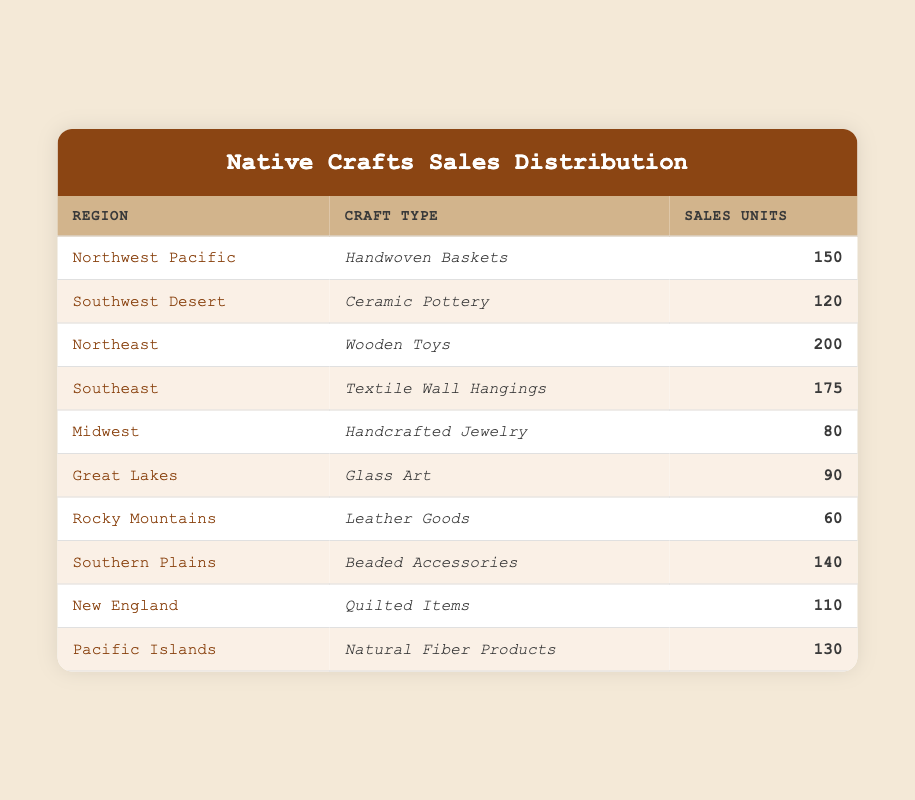What's the total number of sales units for crafts in the Northeast region? The Northeast region has 200 sales units for Wooden Toys. No additional calculations are needed.
Answer: 200 Which craft type sold the least across all regions? The Rocky Mountains had the least sales with Leather Goods at 60 units.
Answer: Leather Goods How many sales units were sold for crafts in the Southern Plains and Southwest Desert combined? Southern Plains has 140 sales units (Beaded Accessories) and Southwest Desert has 120 sales units (Ceramic Pottery). Adding these gives 140 + 120 = 260.
Answer: 260 Is the total sales units for crafts in the Great Lakes and Midwest more than the total for the Southeast? Great Lakes has 90 sales and Midwest has 80 sales, summing these gives 90 + 80 = 170. Southeast has 175 sales units, so 170 is less than 175.
Answer: No What is the average number of sales units across all regions? To find the average, sum all sales units: 150 + 120 + 200 + 175 + 80 + 90 + 60 + 140 + 110 + 130 = 1,255. There are 10 regions, so divide 1,255 by 10, which equals 125.5.
Answer: 125.5 Which region sold more than 150 units of crafts? Looking at the table, the Northeast (200 units) and Southeast (175 units) sold more than 150. No other regions exceed this threshold.
Answer: Northeast and Southeast How many more sales units did the Northeast region have than the Midwest region? The Northeast sold 200 units, and the Midwest sold 80 units. Calculating the difference: 200 - 80 = 120 units more.
Answer: 120 Which two regions together have a sales total less than 200 units? The Rocky Mountains (60 units) and the Midwest (80 units) total to 140 units, which is less than 200. Additionally, the Great Lakes (90 units) and Midwest (80 units) total to 170, also under 200. However, no other combinations exceed these sums.
Answer: Rocky Mountains and Midwest 